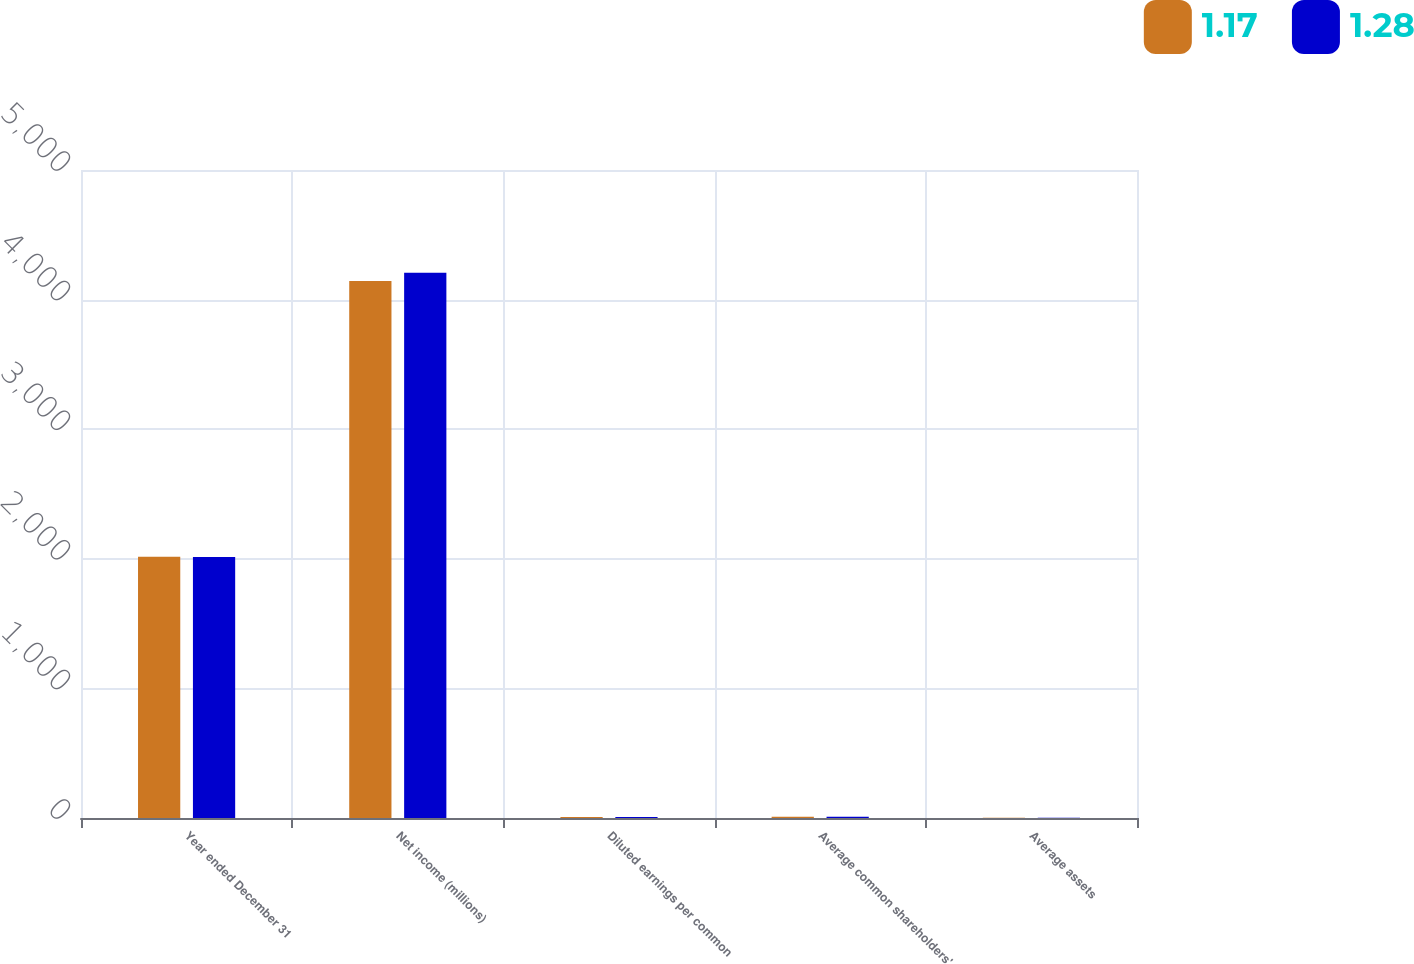<chart> <loc_0><loc_0><loc_500><loc_500><stacked_bar_chart><ecel><fcel>Year ended December 31<fcel>Net income (millions)<fcel>Diluted earnings per common<fcel>Average common shareholders'<fcel>Average assets<nl><fcel>1.17<fcel>2015<fcel>4143<fcel>7.39<fcel>9.5<fcel>1.17<nl><fcel>1.28<fcel>2014<fcel>4207<fcel>7.3<fcel>9.91<fcel>1.28<nl></chart> 